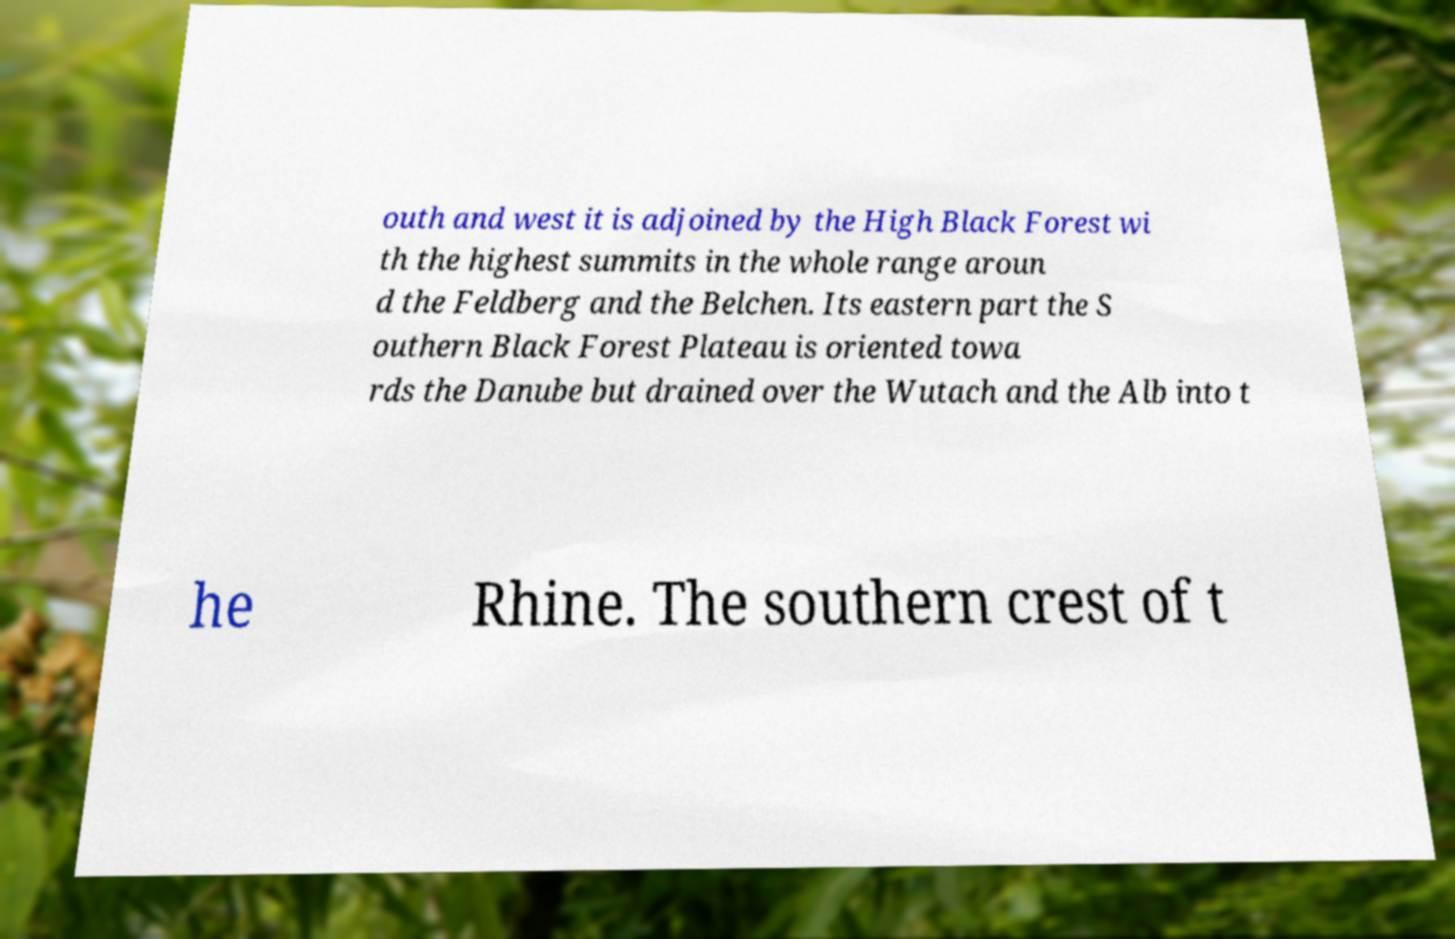Please identify and transcribe the text found in this image. outh and west it is adjoined by the High Black Forest wi th the highest summits in the whole range aroun d the Feldberg and the Belchen. Its eastern part the S outhern Black Forest Plateau is oriented towa rds the Danube but drained over the Wutach and the Alb into t he Rhine. The southern crest of t 